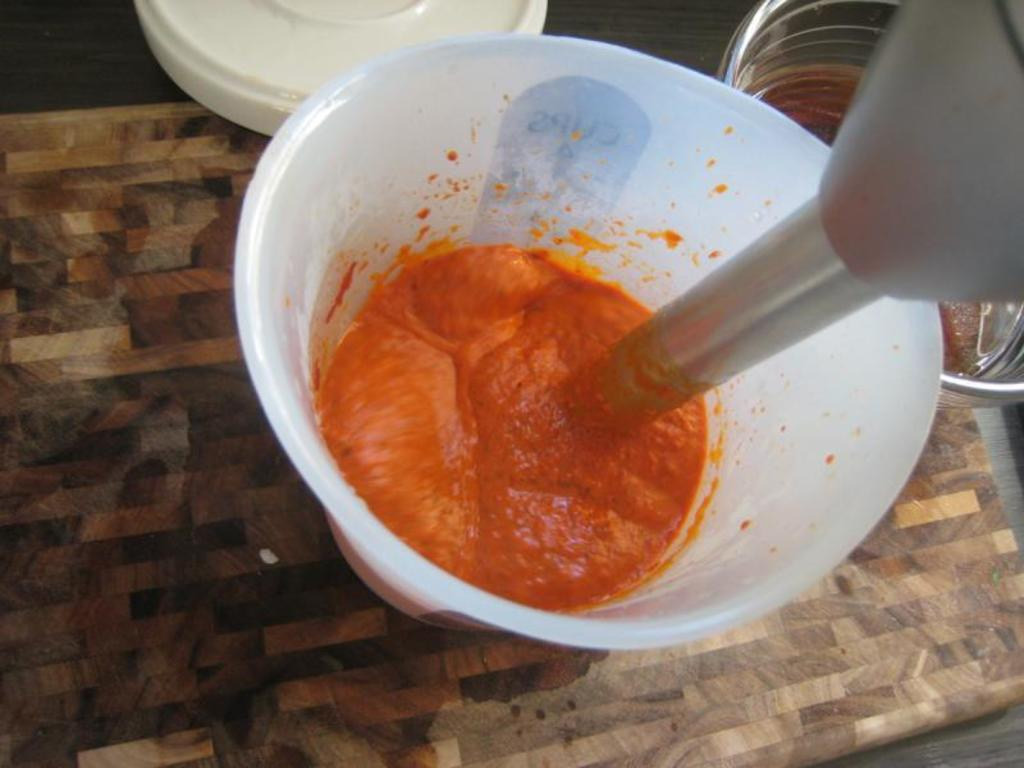What is contained in the glass in the image? There is a food item in a glass in the image. What else is present in the glass besides the food item? There is a machine in the glass. What can be seen on the right side of the image? There is a glass bowl on the right side of the image. What is covering the top of the glass in the image? There is a lid visible at the top of the image. What type of fish can be seen swimming in the image? There is no fish present in the image. 